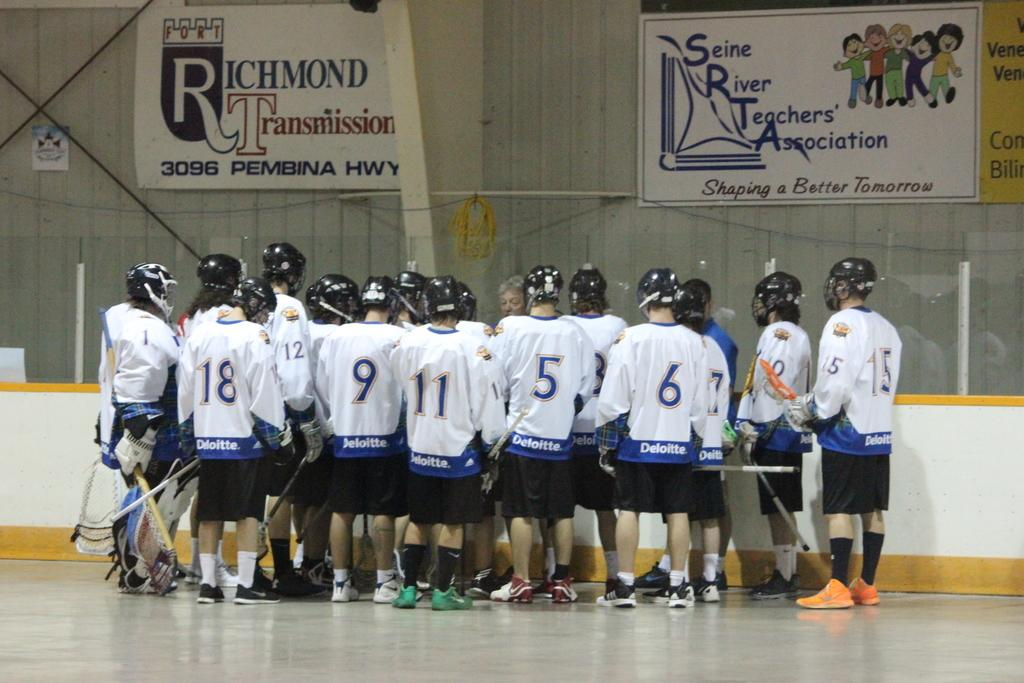What color are the t-shirts worn by the players in the image? The players are wearing white color t-shirts in the image. What is the position of the players in the image? The players are standing on the floor in the image. What can be seen above the players in the image? There are banners above the players in the image. What is located beside the players in the image? There is a white color sheet beside the players in the image. What angle does the wing of the airplane make with the ground in the image? There is no airplane or wing present in the image; it features players wearing white t-shirts. 